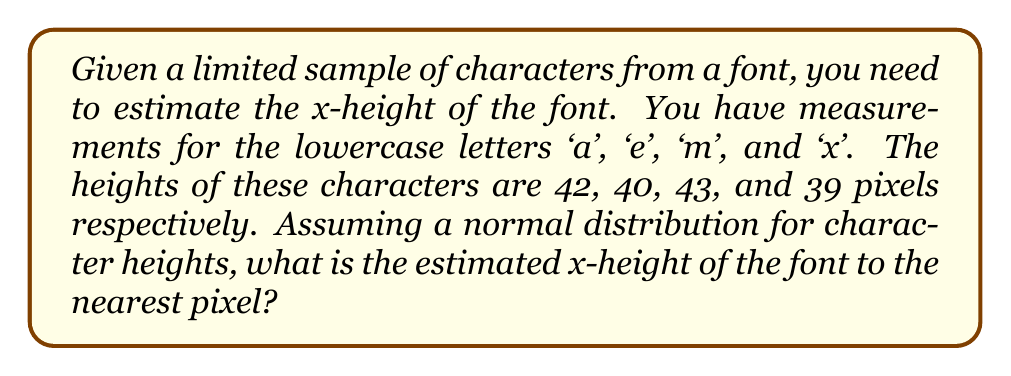Teach me how to tackle this problem. To estimate the x-height of the font from a limited sample, we'll follow these steps:

1. Collect the data:
   'a': 42 pixels
   'e': 40 pixels
   'm': 43 pixels
   'x': 39 pixels

2. Calculate the mean (average) height:
   $$ \text{Mean} = \frac{42 + 40 + 43 + 39}{4} = \frac{164}{4} = 41 \text{ pixels} $$

3. In typography, the x-height is typically defined as the height of lowercase letters without ascenders or descenders, such as 'x'. However, with limited data, we'll use the mean as our best estimate.

4. Round to the nearest pixel:
   41 pixels is already a whole number, so no rounding is necessary.

5. Note on normal distribution:
   While we assumed a normal distribution, with only four data points, we can't reliably calculate standard deviation or perform more advanced statistical analysis. The mean serves as our best estimate given the limited data.

6. For font processing in software development:
   This estimated x-height can be used as a key metric for rendering text, determining line heights, or scaling fonts in PDF handling and text layout algorithms.
Answer: 41 pixels 